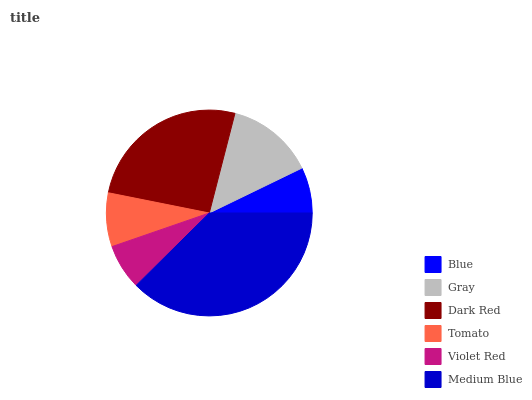Is Violet Red the minimum?
Answer yes or no. Yes. Is Medium Blue the maximum?
Answer yes or no. Yes. Is Gray the minimum?
Answer yes or no. No. Is Gray the maximum?
Answer yes or no. No. Is Gray greater than Blue?
Answer yes or no. Yes. Is Blue less than Gray?
Answer yes or no. Yes. Is Blue greater than Gray?
Answer yes or no. No. Is Gray less than Blue?
Answer yes or no. No. Is Gray the high median?
Answer yes or no. Yes. Is Tomato the low median?
Answer yes or no. Yes. Is Medium Blue the high median?
Answer yes or no. No. Is Dark Red the low median?
Answer yes or no. No. 